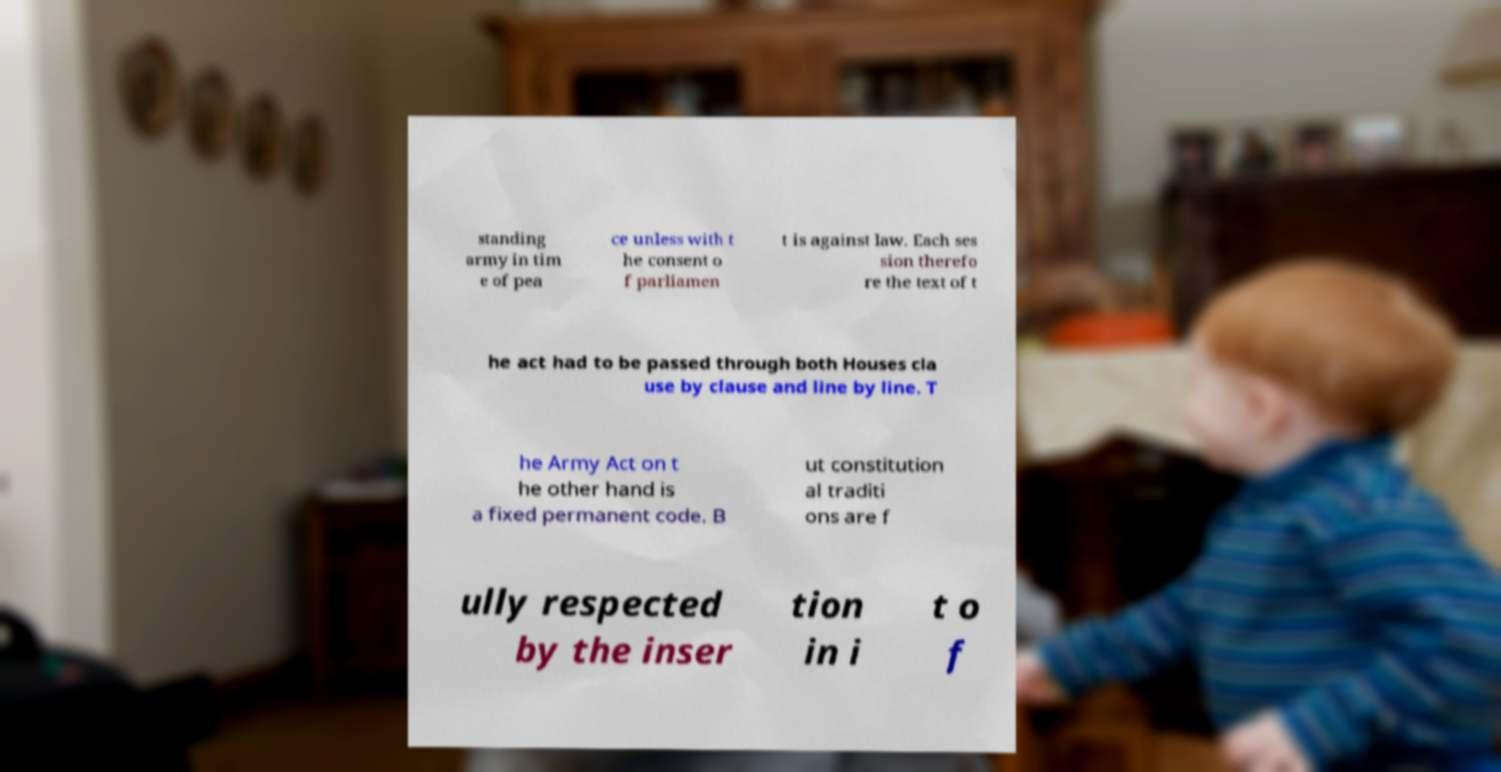Please identify and transcribe the text found in this image. standing army in tim e of pea ce unless with t he consent o f parliamen t is against law. Each ses sion therefo re the text of t he act had to be passed through both Houses cla use by clause and line by line. T he Army Act on t he other hand is a fixed permanent code. B ut constitution al traditi ons are f ully respected by the inser tion in i t o f 